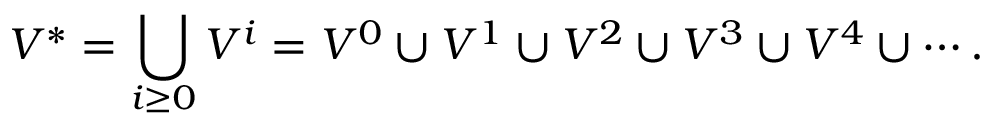Convert formula to latex. <formula><loc_0><loc_0><loc_500><loc_500>V ^ { * } = \bigcup _ { i \geq 0 } V ^ { i } = V ^ { 0 } \cup V ^ { 1 } \cup V ^ { 2 } \cup V ^ { 3 } \cup V ^ { 4 } \cup \cdots .</formula> 